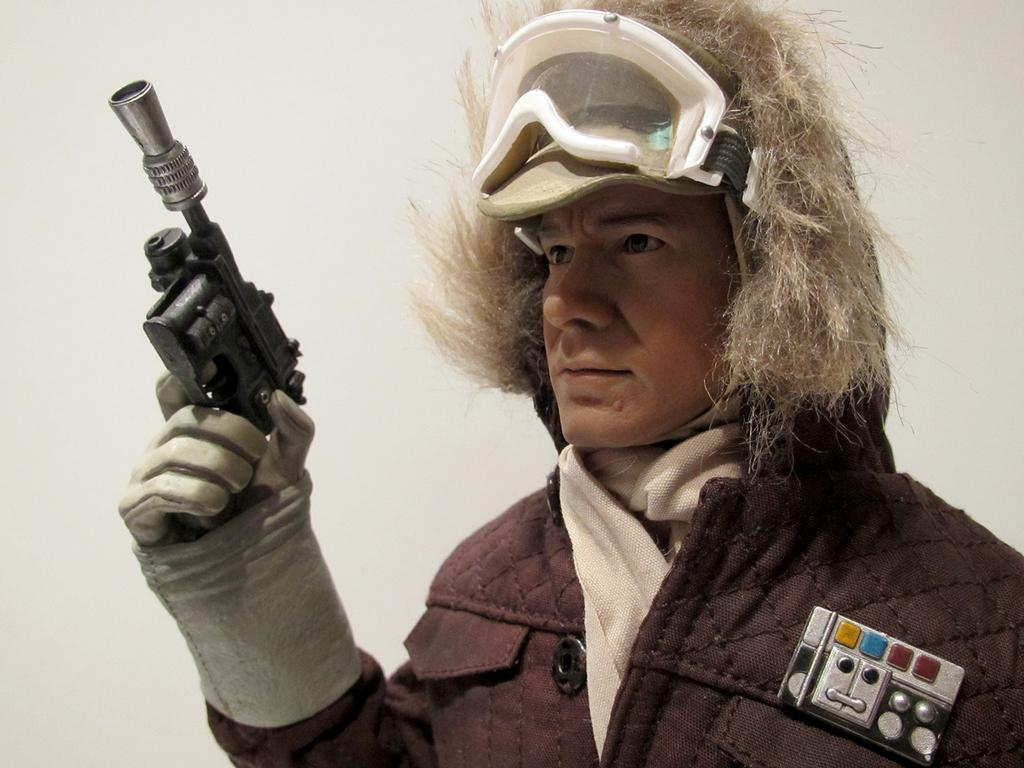What is the main subject of the image? There is a person in the image. What is the person doing in the image? The person is holding an object in his hand. What is the color of the background in the image? The background of the image is white. Can you describe the journey the straw is taking in the image? There is no straw present in the image, so it cannot be described. 